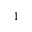<formula> <loc_0><loc_0><loc_500><loc_500>^ { 1 }</formula> 